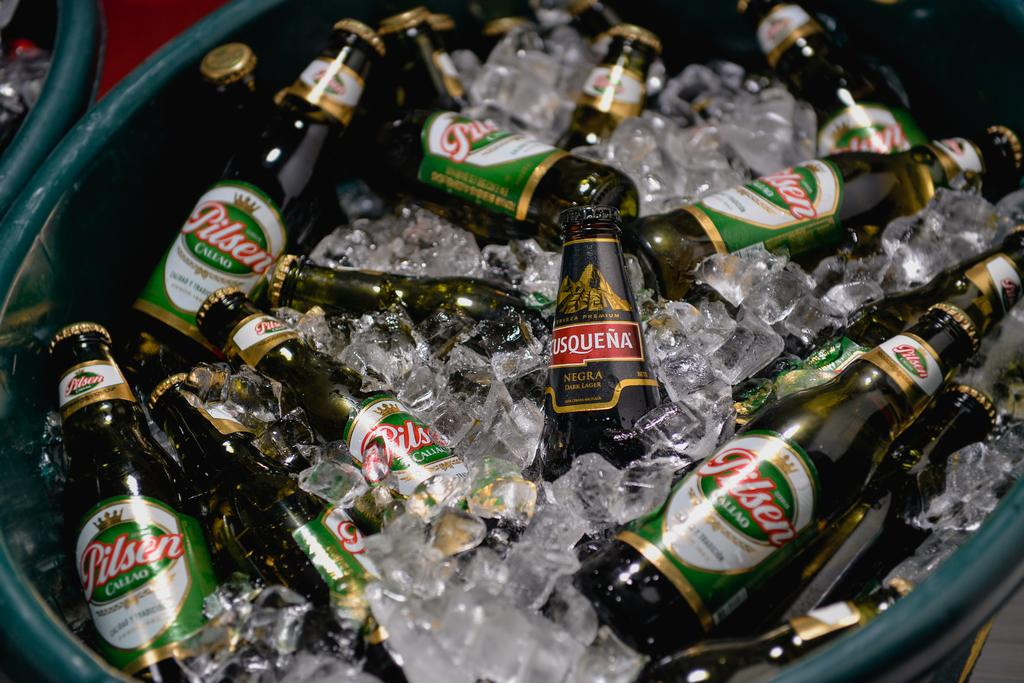What is the focus of the image? The image is zoomed in, with the center showing bottles. What is placed in the green color container? Ice cubes are placed in a green color container. Can you describe the background of the image? There is a green color object in the background of the image. Are there any dinosaurs visible in the image? No, there are no dinosaurs present in the image. What type of desk can be seen in the image? There is no desk visible in the image. 